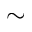Convert formula to latex. <formula><loc_0><loc_0><loc_500><loc_500>\sim</formula> 